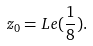Convert formula to latex. <formula><loc_0><loc_0><loc_500><loc_500>z _ { 0 } = L e ( \frac { 1 } { 8 } ) .</formula> 